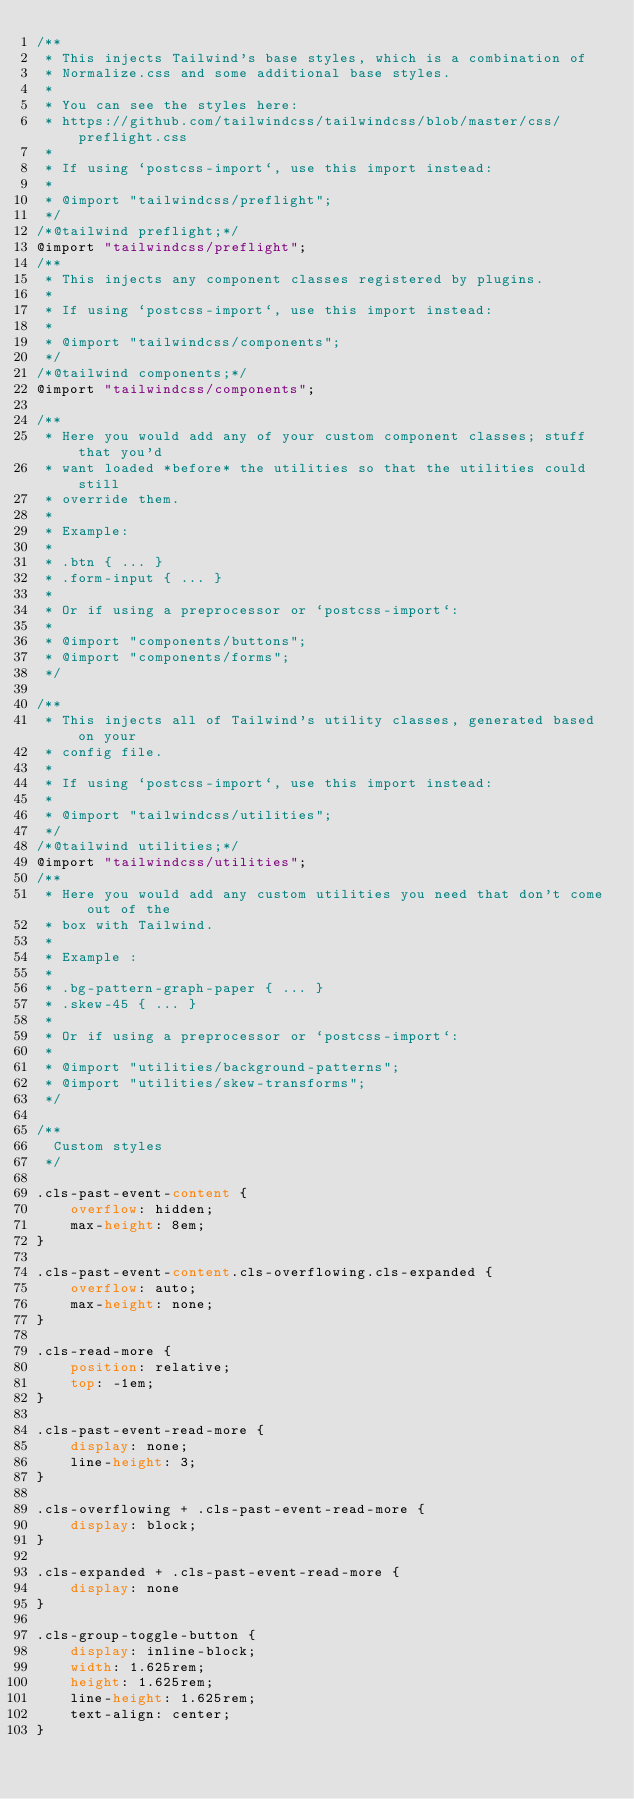Convert code to text. <code><loc_0><loc_0><loc_500><loc_500><_CSS_>/**
 * This injects Tailwind's base styles, which is a combination of
 * Normalize.css and some additional base styles.
 *
 * You can see the styles here:
 * https://github.com/tailwindcss/tailwindcss/blob/master/css/preflight.css
 *
 * If using `postcss-import`, use this import instead:
 *
 * @import "tailwindcss/preflight";
 */
/*@tailwind preflight;*/
@import "tailwindcss/preflight";
/**
 * This injects any component classes registered by plugins.
 *
 * If using `postcss-import`, use this import instead:
 *
 * @import "tailwindcss/components";
 */
/*@tailwind components;*/
@import "tailwindcss/components";

/**
 * Here you would add any of your custom component classes; stuff that you'd
 * want loaded *before* the utilities so that the utilities could still
 * override them.
 *
 * Example:
 *
 * .btn { ... }
 * .form-input { ... }
 *
 * Or if using a preprocessor or `postcss-import`:
 *
 * @import "components/buttons";
 * @import "components/forms";
 */

/**
 * This injects all of Tailwind's utility classes, generated based on your
 * config file.
 *
 * If using `postcss-import`, use this import instead:
 *
 * @import "tailwindcss/utilities";
 */
/*@tailwind utilities;*/
@import "tailwindcss/utilities";
/**
 * Here you would add any custom utilities you need that don't come out of the
 * box with Tailwind.
 *
 * Example :
 *
 * .bg-pattern-graph-paper { ... }
 * .skew-45 { ... }
 *
 * Or if using a preprocessor or `postcss-import`:
 *
 * @import "utilities/background-patterns";
 * @import "utilities/skew-transforms";
 */

/**
  Custom styles
 */

.cls-past-event-content {
    overflow: hidden;
    max-height: 8em;
}

.cls-past-event-content.cls-overflowing.cls-expanded {
    overflow: auto;
    max-height: none;
}

.cls-read-more {
    position: relative;
    top: -1em;
}

.cls-past-event-read-more {
    display: none;
    line-height: 3;
}

.cls-overflowing + .cls-past-event-read-more {
    display: block;
}

.cls-expanded + .cls-past-event-read-more {
    display: none
}

.cls-group-toggle-button {
    display: inline-block;
    width: 1.625rem;
    height: 1.625rem;
    line-height: 1.625rem;
    text-align: center;
}
</code> 